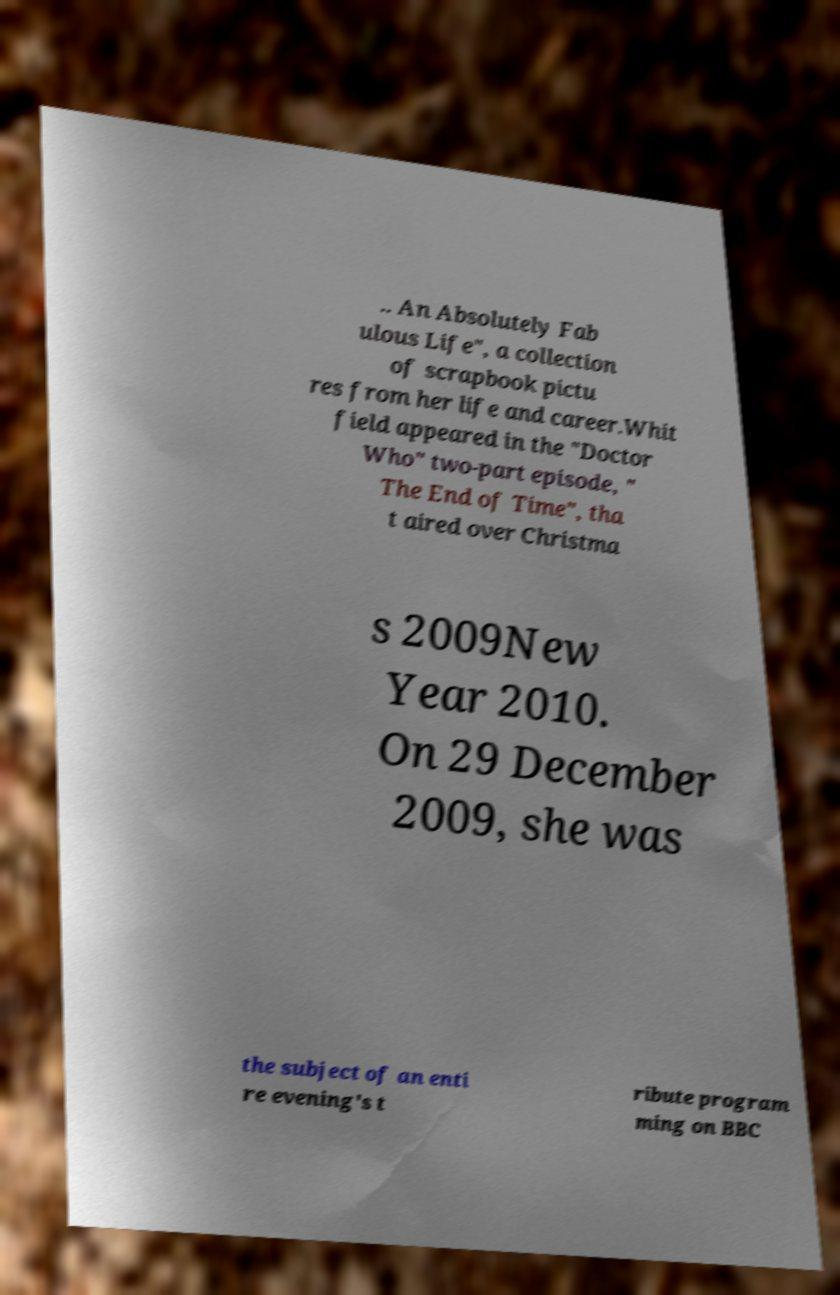What messages or text are displayed in this image? I need them in a readable, typed format. .. An Absolutely Fab ulous Life", a collection of scrapbook pictu res from her life and career.Whit field appeared in the "Doctor Who" two-part episode, " The End of Time", tha t aired over Christma s 2009New Year 2010. On 29 December 2009, she was the subject of an enti re evening's t ribute program ming on BBC 